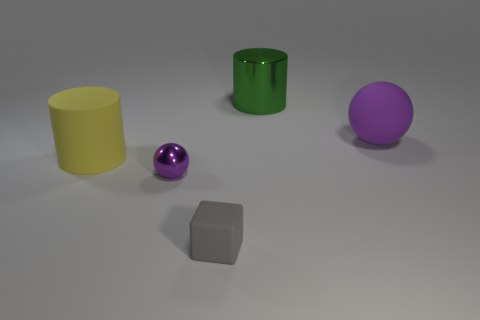Does the purple metallic thing have the same shape as the yellow thing?
Your answer should be compact. No. What number of large things are either yellow objects or rubber objects?
Give a very brief answer. 2. Is the number of yellow cylinders greater than the number of large objects?
Your response must be concise. No. The gray block that is the same material as the big purple sphere is what size?
Offer a very short reply. Small. Is the size of the sphere that is in front of the big purple matte thing the same as the block to the left of the large purple rubber sphere?
Your response must be concise. Yes. What number of things are purple things that are on the left side of the large green metal cylinder or metallic things?
Provide a short and direct response. 2. Are there fewer big purple matte spheres than large purple matte cylinders?
Ensure brevity in your answer.  No. The yellow rubber object on the left side of the rubber object in front of the purple thing left of the big purple matte thing is what shape?
Keep it short and to the point. Cylinder. What is the shape of the large thing that is the same color as the tiny metallic object?
Offer a very short reply. Sphere. Are there any big rubber spheres?
Your answer should be compact. Yes. 